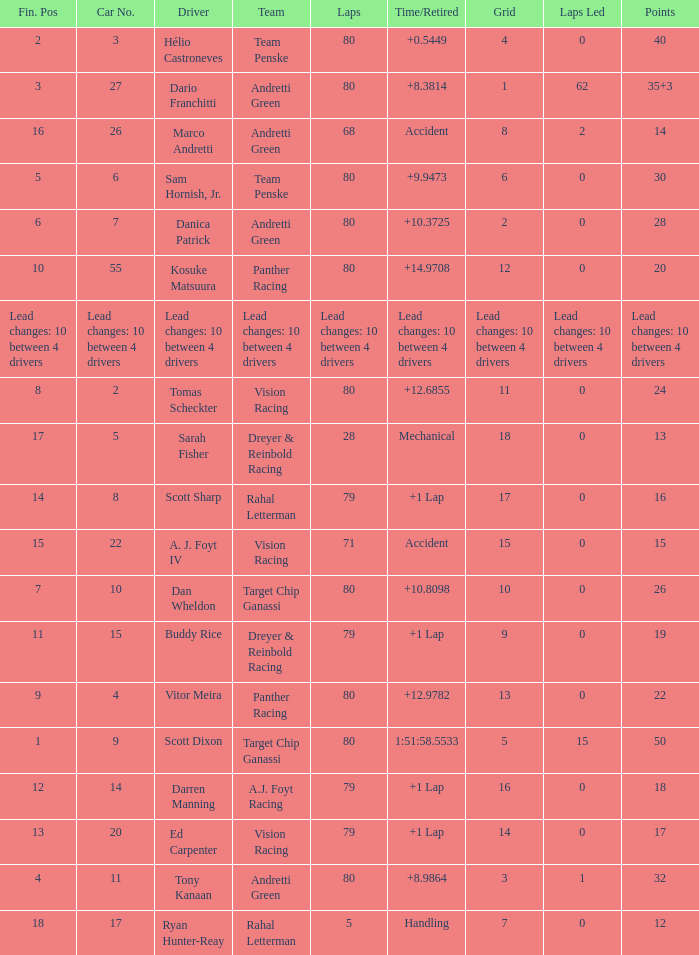How many points does driver kosuke matsuura have? 20.0. 